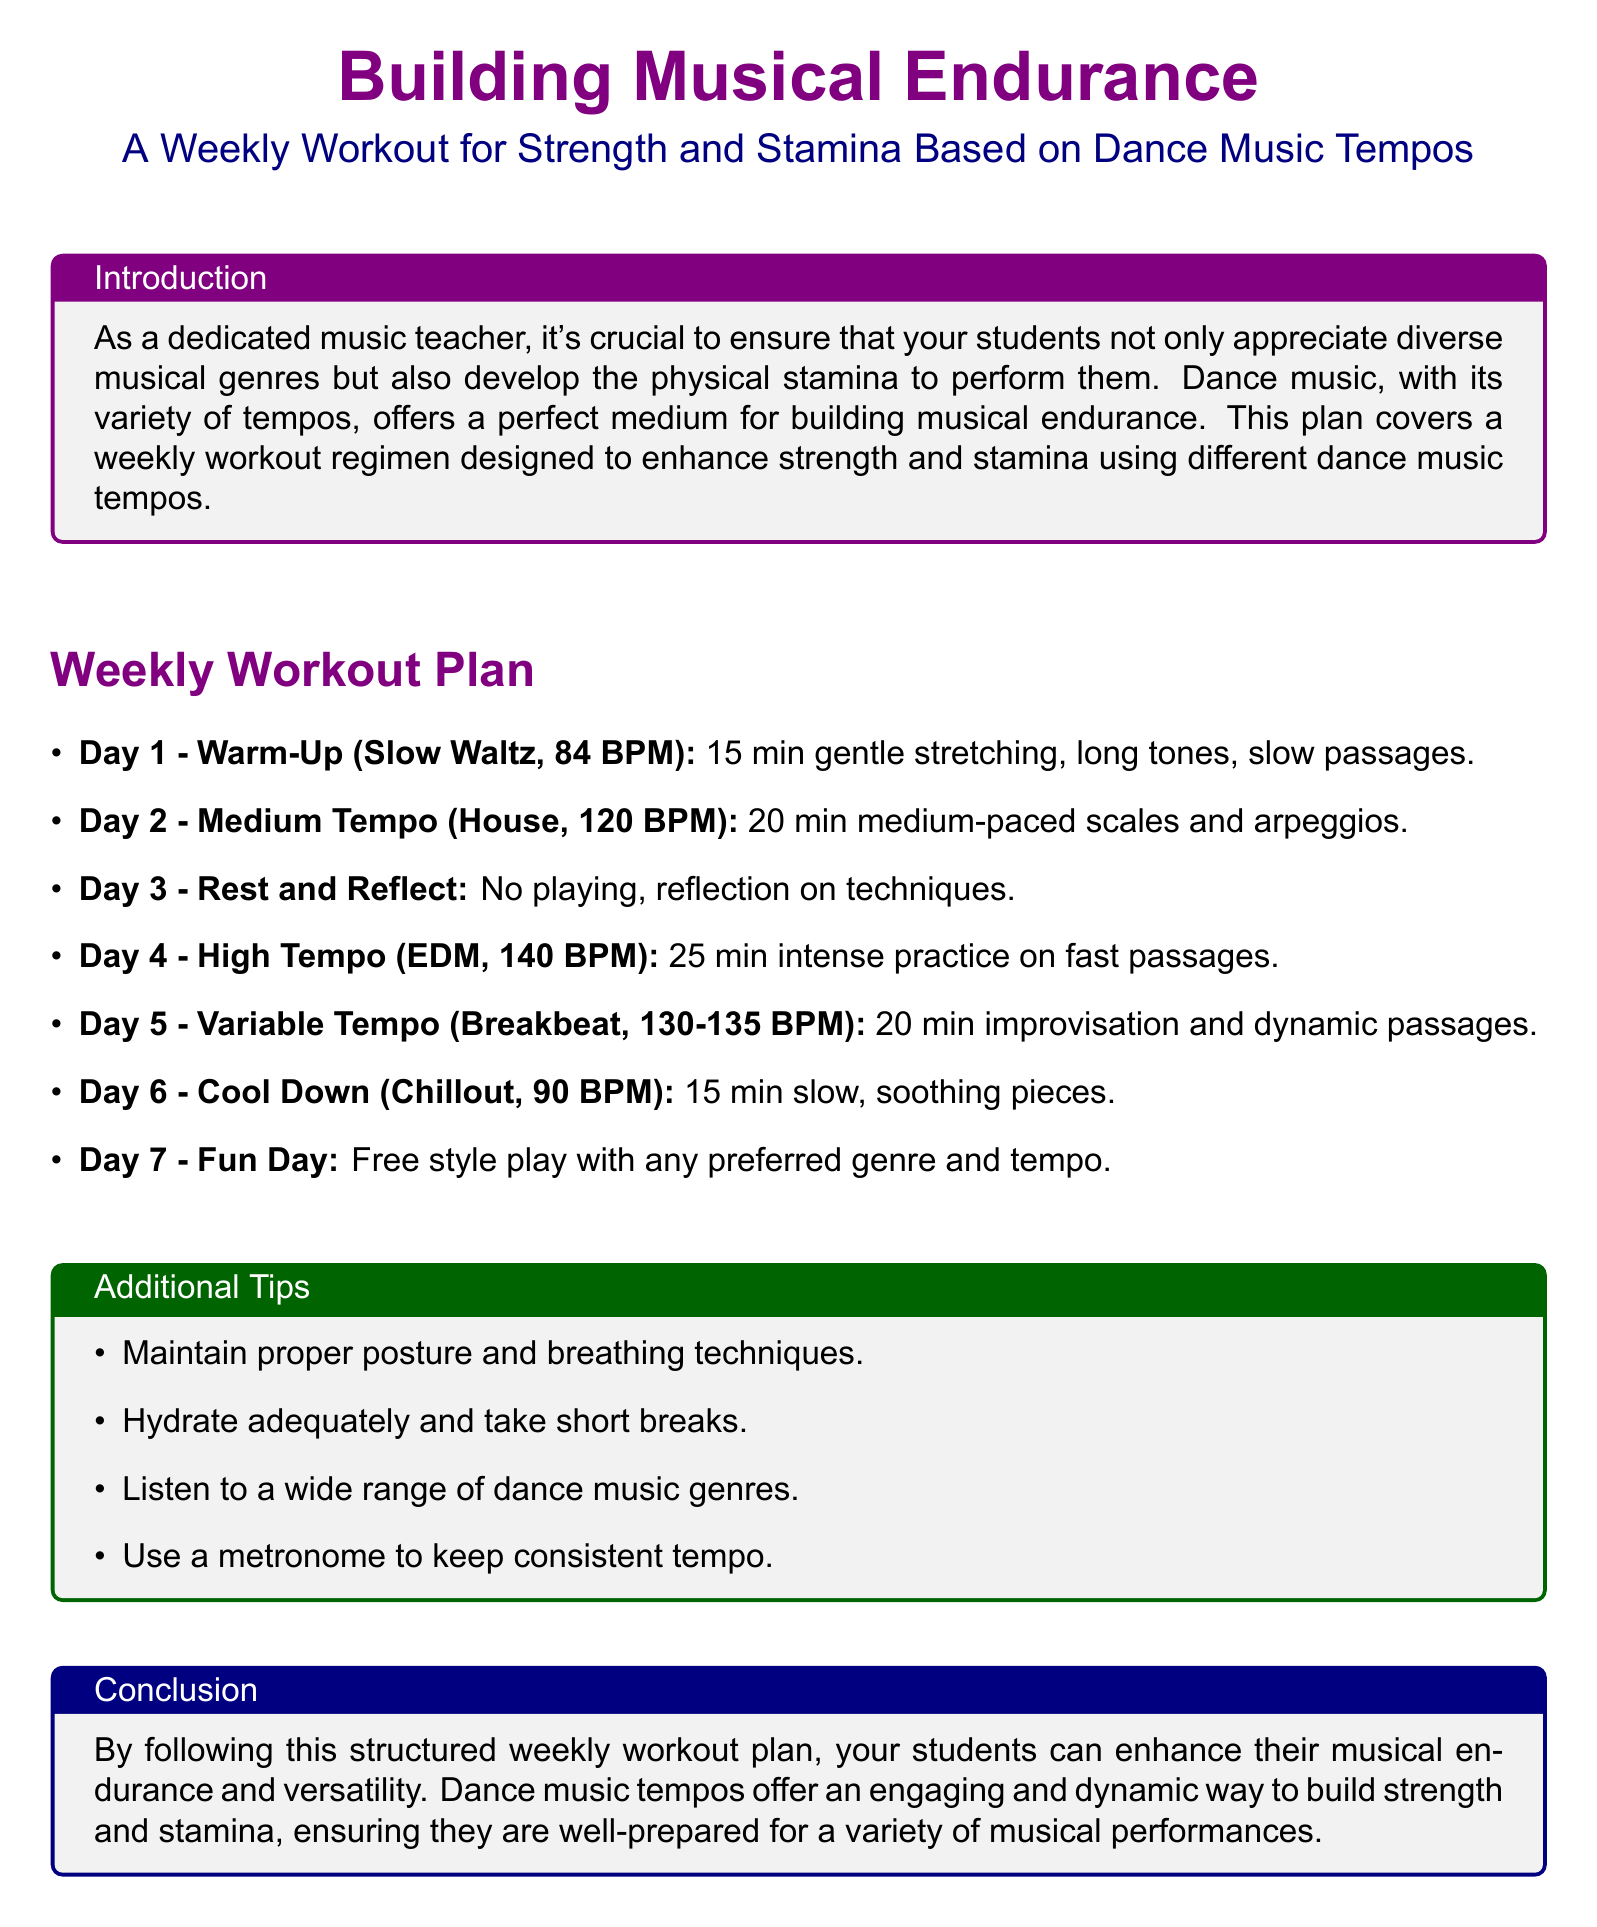What is the tempo for Day 1? The tempo for Day 1 is identified as Slow Waltz at 84 BPM in the document.
Answer: 84 BPM How long is the practice for Day 4? Day 4 includes 25 minutes of intense practice on fast passages.
Answer: 25 min What type of music is associated with Day 2? Day 2 is associated with House music, specifically listed at 120 BPM.
Answer: House What is the focus of Day 3? Day 3 focuses on reflection regarding techniques, with no playing scheduled.
Answer: Reflection What is the suggested activity for Day 6? On Day 6, the activity suggested is playing slow, soothing pieces, characterized by Chillout music at 90 BPM.
Answer: Slow soothing pieces How many days of practice are included in the workout plan? The workout plan includes a total of 7 days, as outlined in the weekly structure.
Answer: 7 days What genre is highlighted for Day 5? The genre highlighted for Day 5 is Breakbeat, which emphasizes improvisation and dynamic passages.
Answer: Breakbeat What is the purpose of the Additional Tips section? The purpose of the Additional Tips section is to provide guidance on posture, hydration, and tempo consistency during practice.
Answer: Guidance 